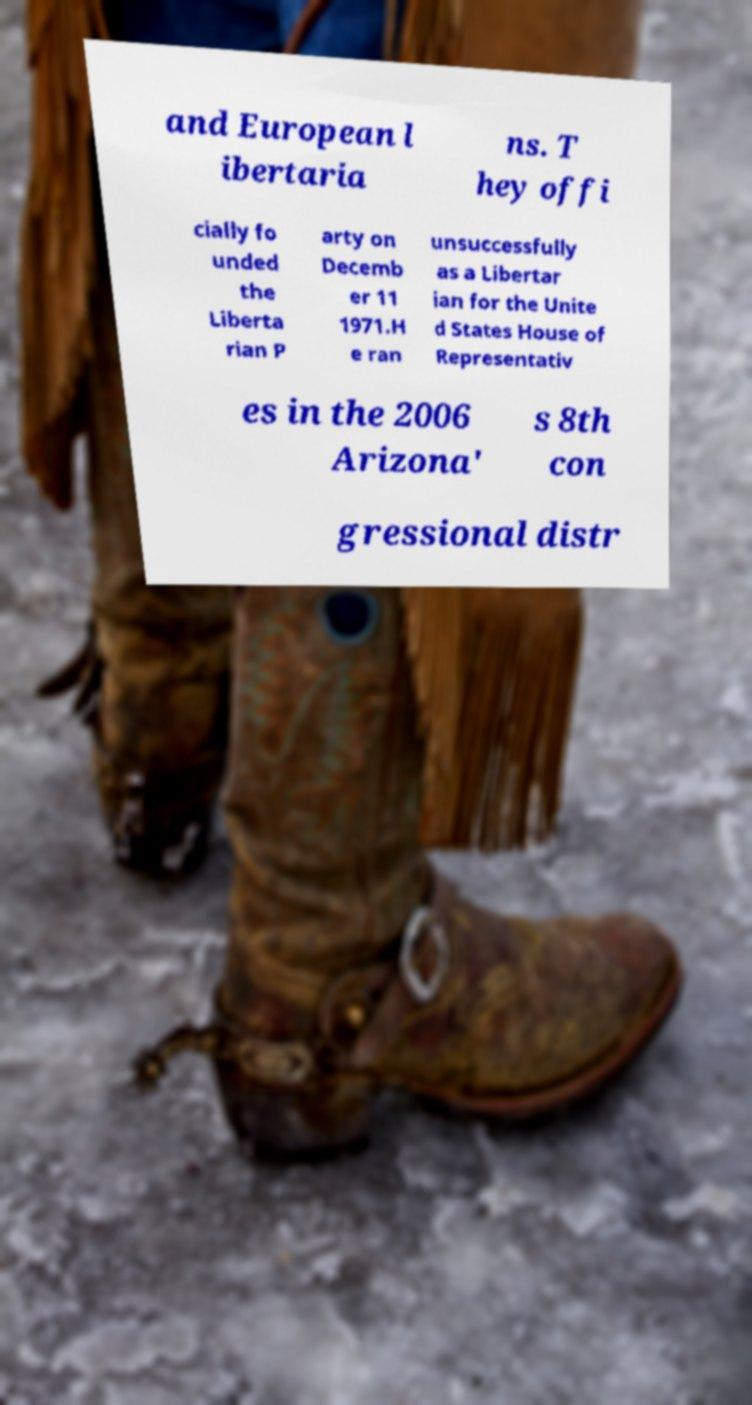Could you extract and type out the text from this image? and European l ibertaria ns. T hey offi cially fo unded the Liberta rian P arty on Decemb er 11 1971.H e ran unsuccessfully as a Libertar ian for the Unite d States House of Representativ es in the 2006 Arizona' s 8th con gressional distr 